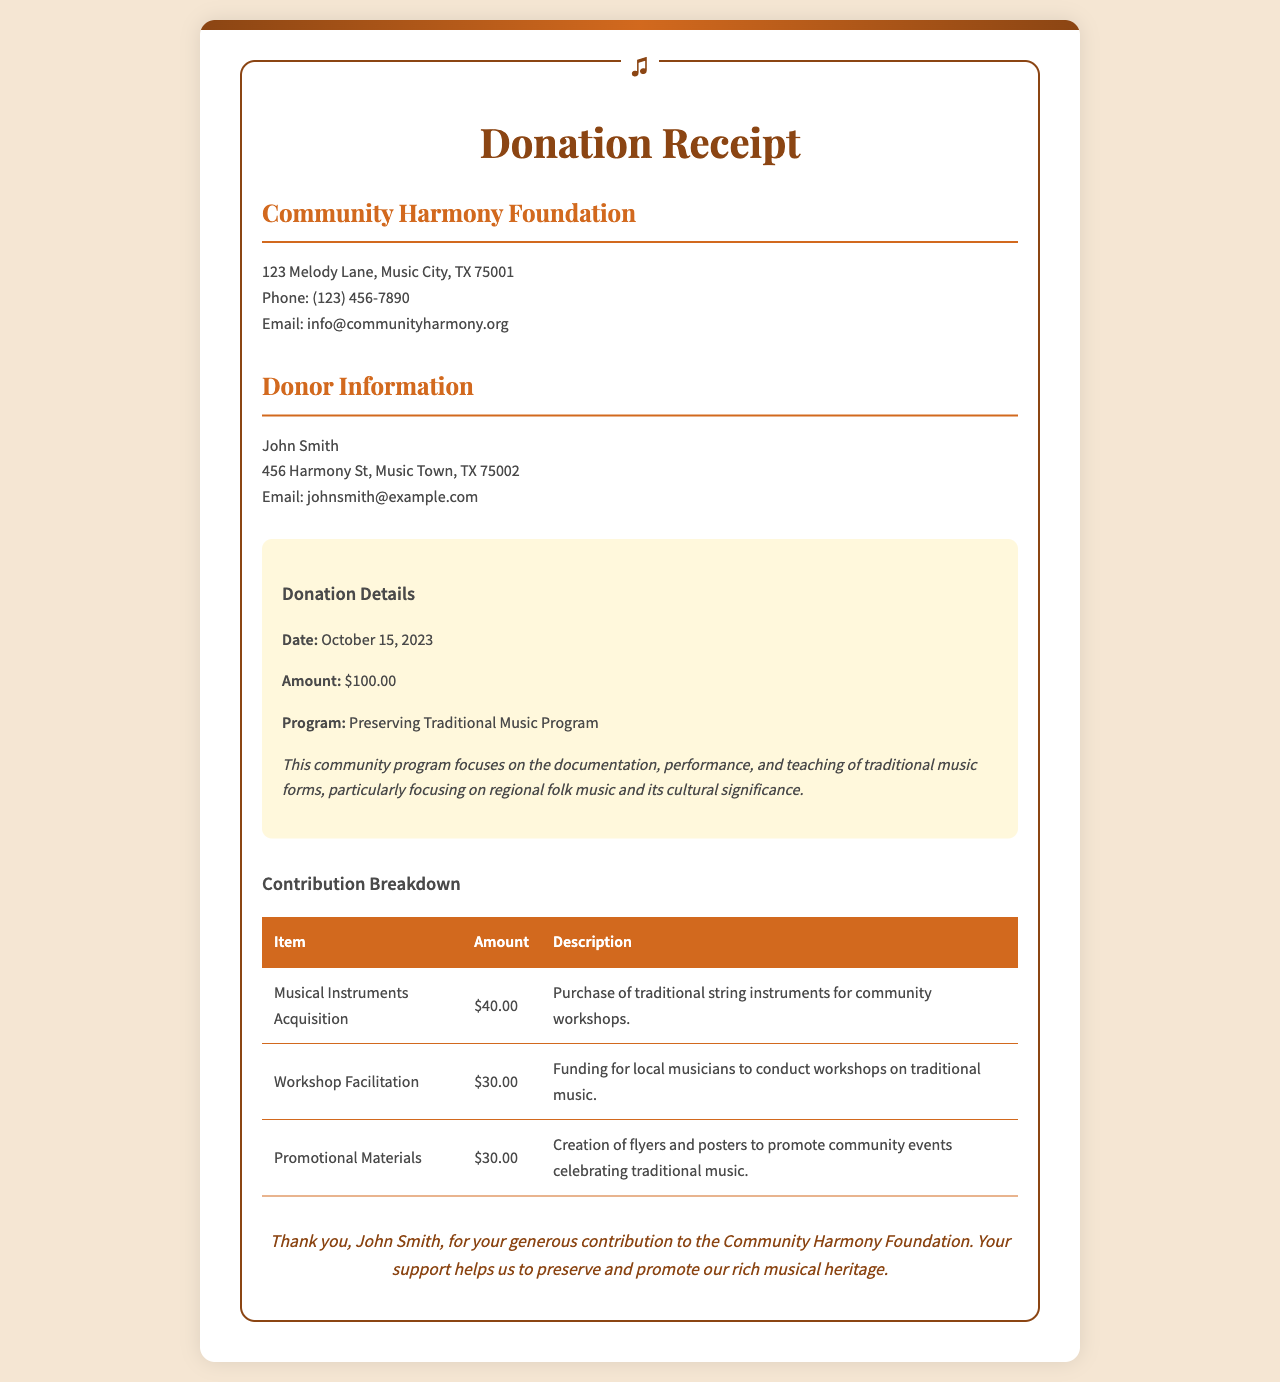What is the name of the organization? The organization's name is prominently displayed at the top of the receipt, highlighting its role in community support.
Answer: Community Harmony Foundation Who is the donor? The donor's name is clearly stated in the document, allowing for acknowledgment of contributions made.
Answer: John Smith What is the date of the donation? The date of the donation is specifically listed in the donation details section of the receipt.
Answer: October 15, 2023 What is the total donation amount? The total amount donated is mentioned in the donation details, indicating the donor's support level.
Answer: $100.00 What program does the donation support? The program supported by the donation is stated to highlight its focus and purpose.
Answer: Preserving Traditional Music Program What was the cost for Musical Instruments Acquisition? The cost for this specific contribution is detailed in the breakdown to provide transparency on fund allocation.
Answer: $40.00 How much was allocated for Workshop Facilitation? The amount designated for this particular effort is found in the contribution breakdown table for clarity.
Answer: $30.00 What is the purpose of the promotional materials? The purpose of promotional materials is explained to illustrate their role in community engagement and event promotion.
Answer: To promote community events celebrating traditional music Thank you message recipient? The thank-you message specifically acknowledges the donor, recognizing their contribution to the foundation.
Answer: John Smith 